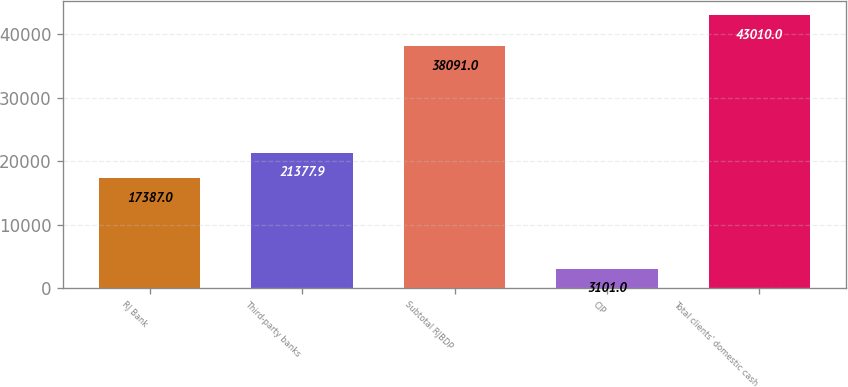Convert chart to OTSL. <chart><loc_0><loc_0><loc_500><loc_500><bar_chart><fcel>RJ Bank<fcel>Third-party banks<fcel>Subtotal RJBDP<fcel>CIP<fcel>Total clients' domestic cash<nl><fcel>17387<fcel>21377.9<fcel>38091<fcel>3101<fcel>43010<nl></chart> 